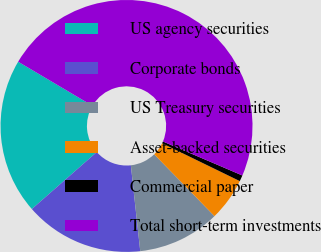Convert chart to OTSL. <chart><loc_0><loc_0><loc_500><loc_500><pie_chart><fcel>US agency securities<fcel>Corporate bonds<fcel>US Treasury securities<fcel>Asset-backed securities<fcel>Commercial paper<fcel>Total short-term investments<nl><fcel>19.98%<fcel>15.27%<fcel>10.56%<fcel>5.49%<fcel>0.78%<fcel>47.92%<nl></chart> 